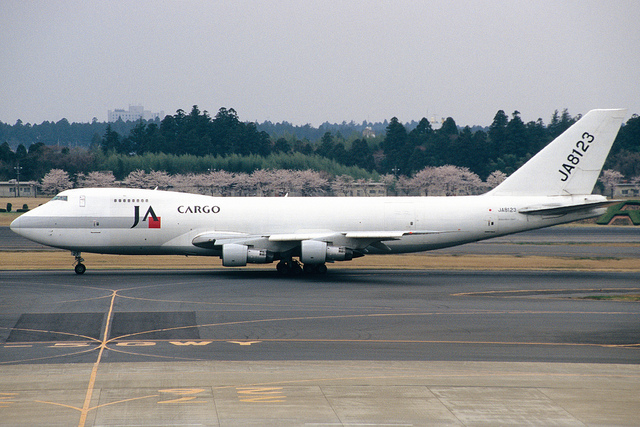Identify the text contained in this image. JA CARGO JA8123 